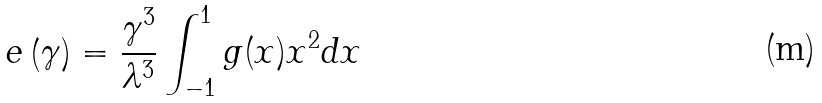<formula> <loc_0><loc_0><loc_500><loc_500>e \left ( \gamma \right ) = \frac { \gamma ^ { 3 } } { \lambda ^ { 3 } } \int _ { - 1 } ^ { 1 } g ( x ) x ^ { 2 } d x</formula> 